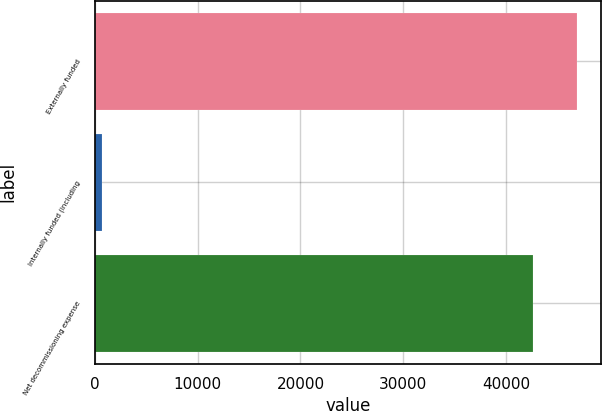Convert chart. <chart><loc_0><loc_0><loc_500><loc_500><bar_chart><fcel>Externally funded<fcel>Internally funded (including<fcel>Net decommissioning expense<nl><fcel>46896.3<fcel>759<fcel>42633<nl></chart> 